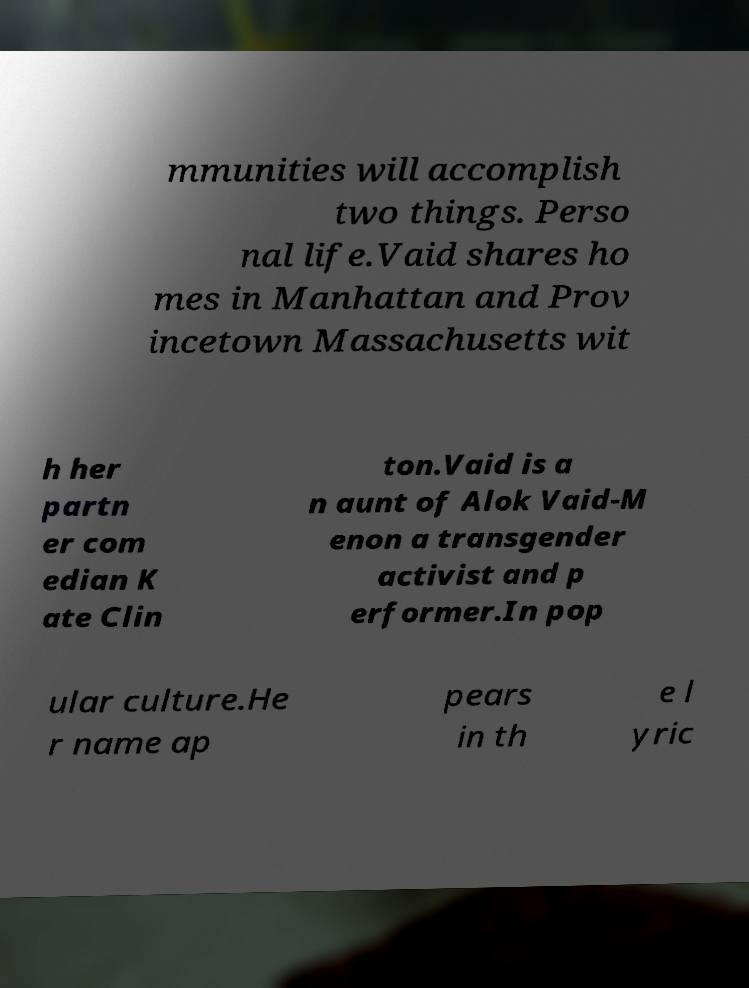Can you accurately transcribe the text from the provided image for me? mmunities will accomplish two things. Perso nal life.Vaid shares ho mes in Manhattan and Prov incetown Massachusetts wit h her partn er com edian K ate Clin ton.Vaid is a n aunt of Alok Vaid-M enon a transgender activist and p erformer.In pop ular culture.He r name ap pears in th e l yric 